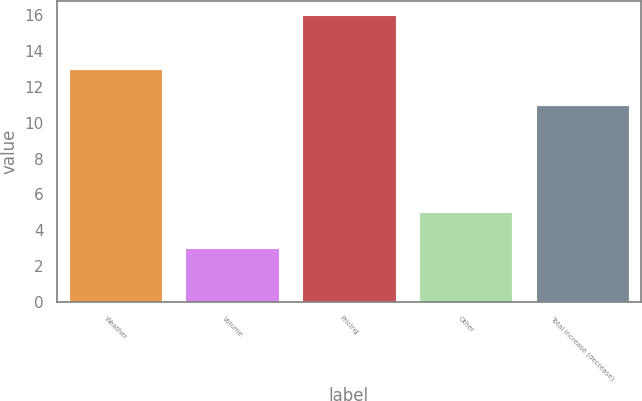Convert chart to OTSL. <chart><loc_0><loc_0><loc_500><loc_500><bar_chart><fcel>Weather<fcel>Volume<fcel>Pricing<fcel>Other<fcel>Total increase (decrease)<nl><fcel>13<fcel>3<fcel>16<fcel>5<fcel>11<nl></chart> 